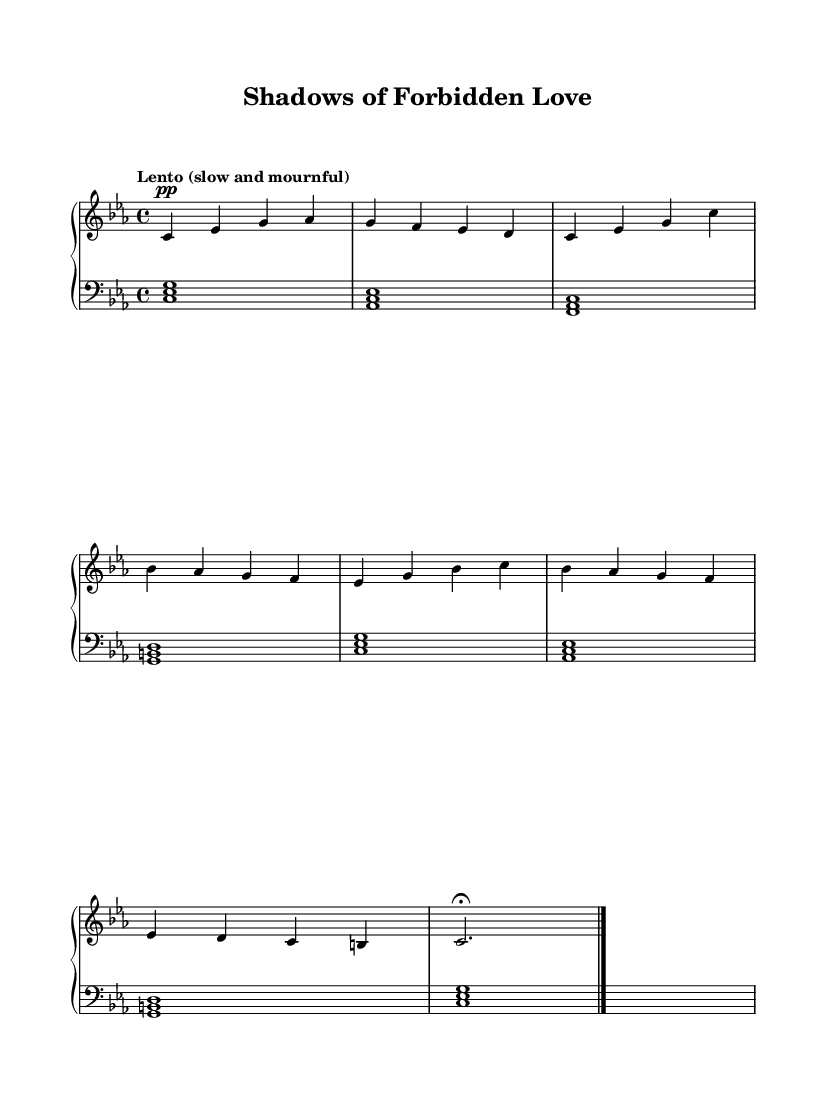What is the key signature of this music? The key signature is C minor, which includes three flats: B flat, E flat, and A flat. This is indicated at the beginning of the staff.
Answer: C minor What is the time signature of this piece? The time signature indicated at the beginning of the score is 4/4, which means there are four beats in each measure and the quarter note gets one beat.
Answer: 4/4 What is the tempo marking for the piece? The tempo marking is "Lento," which means slow and mournful, as indicated above the staff.
Answer: Lento How many measures are in the music? There are a total of 8 measures as counted from the beginning to the final ending point marked by the bar line.
Answer: 8 What is the dynamic marking of the right-hand melody in the first measure? The dynamic marking is "pp," which stands for pianissimo, indicating that the music should be played very softly. This marking is shown below the first note in the right hand.
Answer: pp What is the final note of the right-hand melody? The final note of the right-hand melody is a C note, which appears in the eighth measure before the fermata. It is held longer than usual.
Answer: C Which chord is played in the left hand during the first measure? The left hand plays the chord C minor, consisting of the notes C, E flat, and G, which is represented by the chord symbol at the start of the first measure.
Answer: C minor 